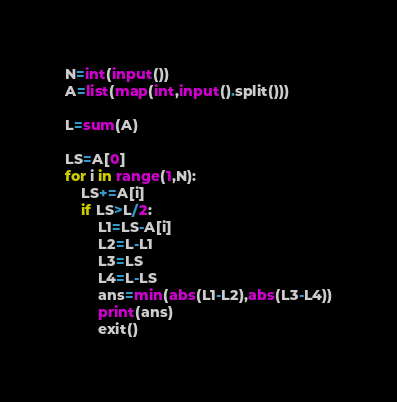Convert code to text. <code><loc_0><loc_0><loc_500><loc_500><_Python_>N=int(input())
A=list(map(int,input().split()))

L=sum(A)

LS=A[0]
for i in range(1,N):
    LS+=A[i]
    if LS>L/2:
        L1=LS-A[i]
        L2=L-L1
        L3=LS
        L4=L-LS
        ans=min(abs(L1-L2),abs(L3-L4))
        print(ans)
        exit()


</code> 